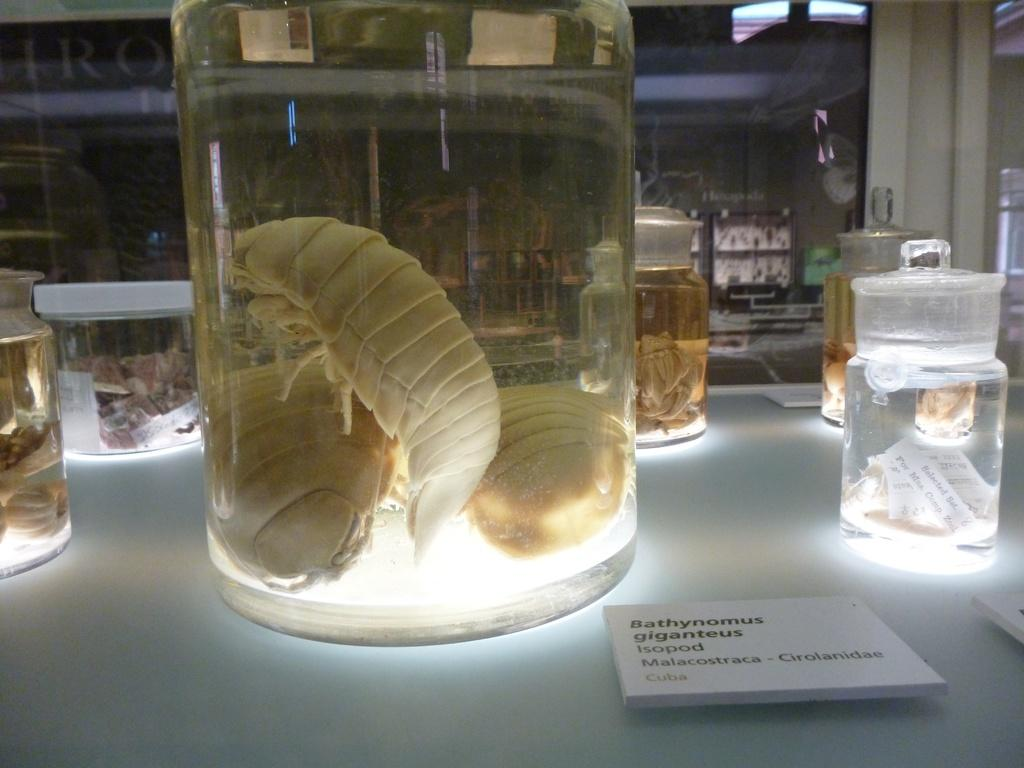Provide a one-sentence caption for the provided image. Several enormous bugs are in a jar beside a label that says Bathynomus Giganteus. 